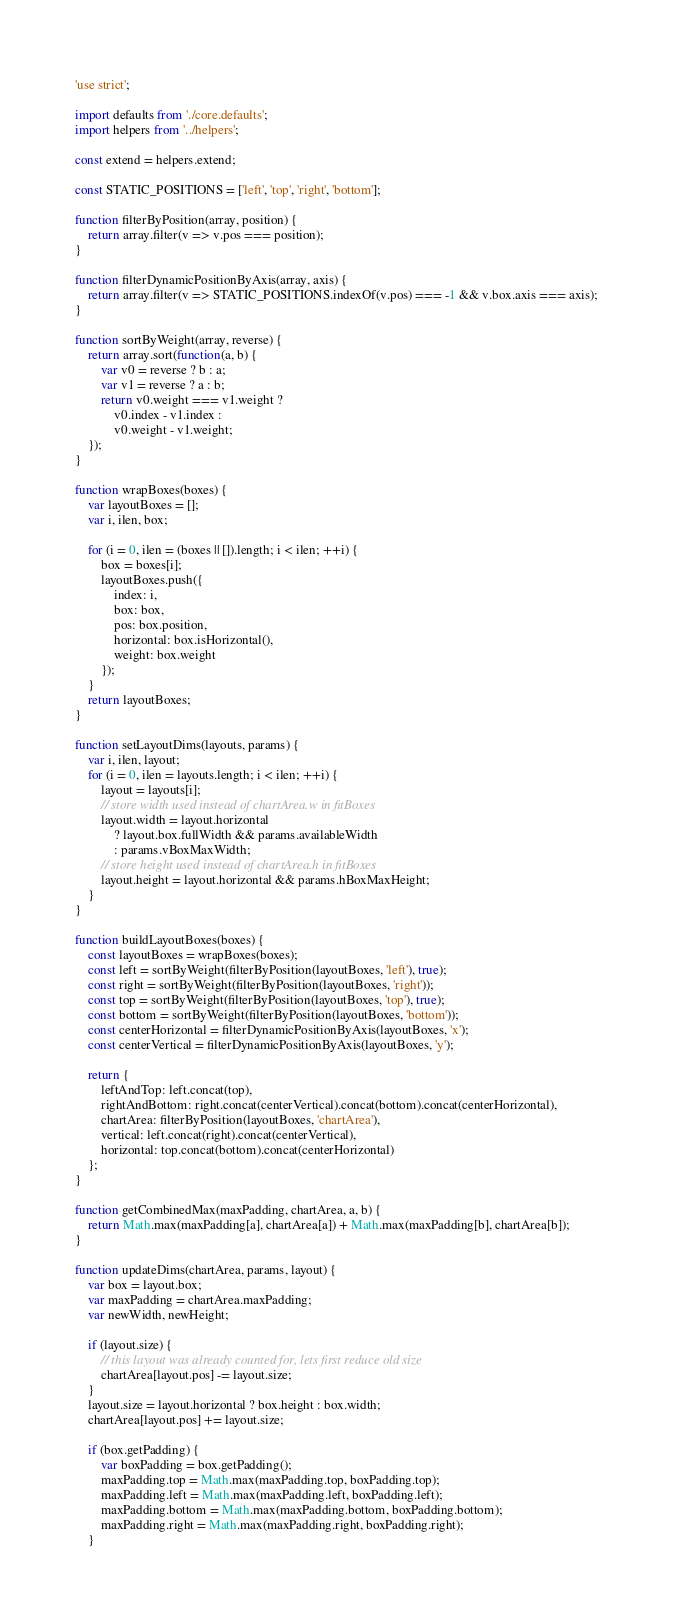<code> <loc_0><loc_0><loc_500><loc_500><_JavaScript_>'use strict';

import defaults from './core.defaults';
import helpers from '../helpers';

const extend = helpers.extend;

const STATIC_POSITIONS = ['left', 'top', 'right', 'bottom'];

function filterByPosition(array, position) {
	return array.filter(v => v.pos === position);
}

function filterDynamicPositionByAxis(array, axis) {
	return array.filter(v => STATIC_POSITIONS.indexOf(v.pos) === -1 && v.box.axis === axis);
}

function sortByWeight(array, reverse) {
	return array.sort(function(a, b) {
		var v0 = reverse ? b : a;
		var v1 = reverse ? a : b;
		return v0.weight === v1.weight ?
			v0.index - v1.index :
			v0.weight - v1.weight;
	});
}

function wrapBoxes(boxes) {
	var layoutBoxes = [];
	var i, ilen, box;

	for (i = 0, ilen = (boxes || []).length; i < ilen; ++i) {
		box = boxes[i];
		layoutBoxes.push({
			index: i,
			box: box,
			pos: box.position,
			horizontal: box.isHorizontal(),
			weight: box.weight
		});
	}
	return layoutBoxes;
}

function setLayoutDims(layouts, params) {
	var i, ilen, layout;
	for (i = 0, ilen = layouts.length; i < ilen; ++i) {
		layout = layouts[i];
		// store width used instead of chartArea.w in fitBoxes
		layout.width = layout.horizontal
			? layout.box.fullWidth && params.availableWidth
			: params.vBoxMaxWidth;
		// store height used instead of chartArea.h in fitBoxes
		layout.height = layout.horizontal && params.hBoxMaxHeight;
	}
}

function buildLayoutBoxes(boxes) {
	const layoutBoxes = wrapBoxes(boxes);
	const left = sortByWeight(filterByPosition(layoutBoxes, 'left'), true);
	const right = sortByWeight(filterByPosition(layoutBoxes, 'right'));
	const top = sortByWeight(filterByPosition(layoutBoxes, 'top'), true);
	const bottom = sortByWeight(filterByPosition(layoutBoxes, 'bottom'));
	const centerHorizontal = filterDynamicPositionByAxis(layoutBoxes, 'x');
	const centerVertical = filterDynamicPositionByAxis(layoutBoxes, 'y');

	return {
		leftAndTop: left.concat(top),
		rightAndBottom: right.concat(centerVertical).concat(bottom).concat(centerHorizontal),
		chartArea: filterByPosition(layoutBoxes, 'chartArea'),
		vertical: left.concat(right).concat(centerVertical),
		horizontal: top.concat(bottom).concat(centerHorizontal)
	};
}

function getCombinedMax(maxPadding, chartArea, a, b) {
	return Math.max(maxPadding[a], chartArea[a]) + Math.max(maxPadding[b], chartArea[b]);
}

function updateDims(chartArea, params, layout) {
	var box = layout.box;
	var maxPadding = chartArea.maxPadding;
	var newWidth, newHeight;

	if (layout.size) {
		// this layout was already counted for, lets first reduce old size
		chartArea[layout.pos] -= layout.size;
	}
	layout.size = layout.horizontal ? box.height : box.width;
	chartArea[layout.pos] += layout.size;

	if (box.getPadding) {
		var boxPadding = box.getPadding();
		maxPadding.top = Math.max(maxPadding.top, boxPadding.top);
		maxPadding.left = Math.max(maxPadding.left, boxPadding.left);
		maxPadding.bottom = Math.max(maxPadding.bottom, boxPadding.bottom);
		maxPadding.right = Math.max(maxPadding.right, boxPadding.right);
	}
</code> 